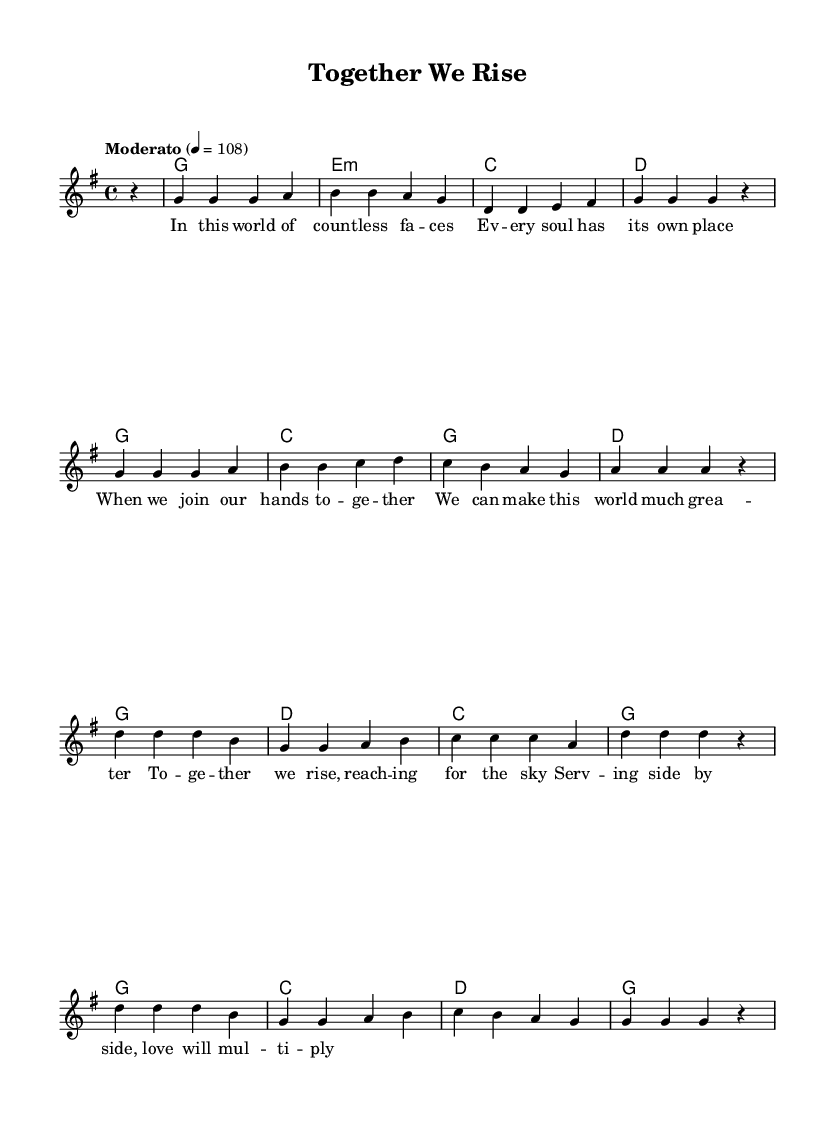What is the key signature of this music? The key signature is G major, which has one sharp (F#). This is determined by the presence of the F# note in the melody and chords shown.
Answer: G major What is the time signature of this music? The time signature is 4/4, indicated near the beginning of the sheet music. This means there are four beats per measure and a quarter note receives one beat.
Answer: 4/4 What is the tempo marking of this music? The tempo marking is "Moderato," which means at a moderate speed. The numerical indication specifies a beats-per-minute value of 108.
Answer: Moderato How many measures are in the verse? The verse comprises eight measures of music, as indicated by the sequences of notes and rests grouped into sets bounded by vertical bar lines.
Answer: Eight Which chord is played at the end of the first measure? The first measure ends with a G major chord, which is discernible from the chord names given at the beginning of the measures.
Answer: G What is the main theme of the lyrics? The primary theme of the lyrics revolves around unity and service, emphasizing coming together and making the world better, as expressed in the phrases describing connection and cooperation.
Answer: Unity In which section do the lyrics state "Together we rise"? This phrase appears in the chorus section of the song, indicating a climactic moment that emphasizes collective strength and hope.
Answer: Chorus 